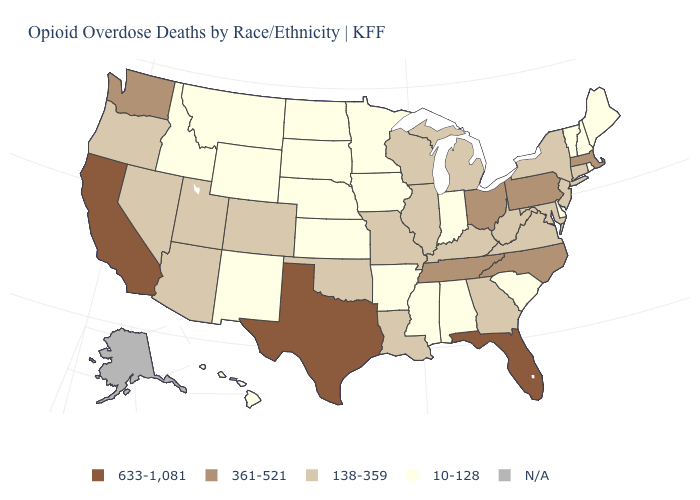Among the states that border Utah , does Wyoming have the highest value?
Give a very brief answer. No. How many symbols are there in the legend?
Short answer required. 5. What is the lowest value in the USA?
Give a very brief answer. 10-128. Name the states that have a value in the range 138-359?
Keep it brief. Arizona, Colorado, Connecticut, Georgia, Illinois, Kentucky, Louisiana, Maryland, Michigan, Missouri, Nevada, New Jersey, New York, Oklahoma, Oregon, Utah, Virginia, West Virginia, Wisconsin. Does Texas have the highest value in the USA?
Concise answer only. Yes. What is the highest value in the MidWest ?
Keep it brief. 361-521. Among the states that border North Carolina , which have the highest value?
Short answer required. Tennessee. What is the value of Kentucky?
Be succinct. 138-359. Does New York have the lowest value in the Northeast?
Concise answer only. No. Name the states that have a value in the range N/A?
Keep it brief. Alaska. What is the lowest value in the USA?
Concise answer only. 10-128. What is the value of West Virginia?
Short answer required. 138-359. Which states have the highest value in the USA?
Be succinct. California, Florida, Texas. What is the value of Wisconsin?
Short answer required. 138-359. How many symbols are there in the legend?
Concise answer only. 5. 